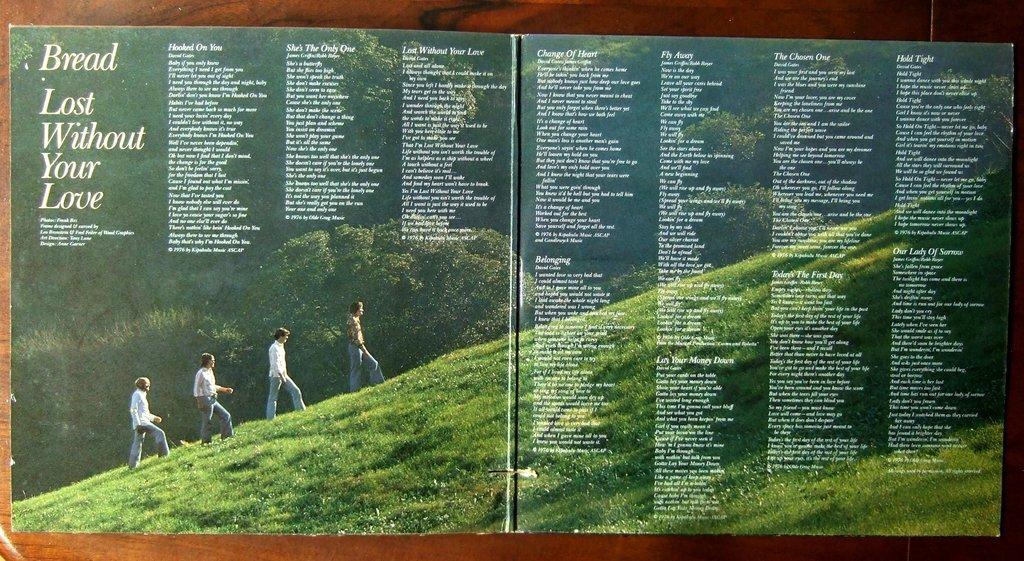Describe this image in one or two sentences. In this image I can see four persons are walking on grass, trees and text. This image looks like a wall painting on a wall taken may be during a day. 